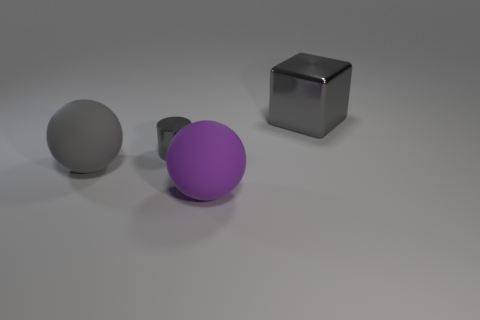Add 2 big blue objects. How many objects exist? 6 Subtract all cylinders. How many objects are left? 3 Subtract all purple cylinders. Subtract all brown spheres. How many cylinders are left? 1 Add 4 metallic things. How many metallic things are left? 6 Add 2 balls. How many balls exist? 4 Subtract 1 gray cubes. How many objects are left? 3 Subtract all rubber balls. Subtract all large blocks. How many objects are left? 1 